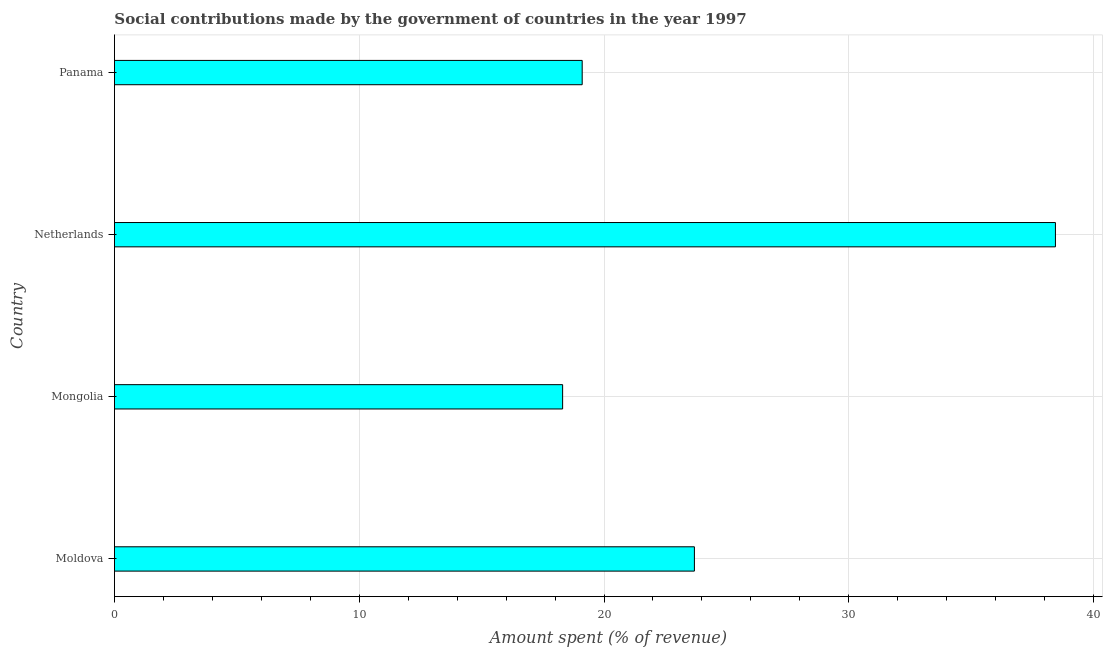Does the graph contain any zero values?
Provide a succinct answer. No. Does the graph contain grids?
Offer a terse response. Yes. What is the title of the graph?
Keep it short and to the point. Social contributions made by the government of countries in the year 1997. What is the label or title of the X-axis?
Your answer should be very brief. Amount spent (% of revenue). What is the amount spent in making social contributions in Mongolia?
Your answer should be very brief. 18.31. Across all countries, what is the maximum amount spent in making social contributions?
Your answer should be very brief. 38.44. Across all countries, what is the minimum amount spent in making social contributions?
Your answer should be compact. 18.31. In which country was the amount spent in making social contributions maximum?
Offer a terse response. Netherlands. In which country was the amount spent in making social contributions minimum?
Your answer should be very brief. Mongolia. What is the sum of the amount spent in making social contributions?
Ensure brevity in your answer.  99.56. What is the difference between the amount spent in making social contributions in Moldova and Netherlands?
Ensure brevity in your answer.  -14.75. What is the average amount spent in making social contributions per country?
Offer a very short reply. 24.89. What is the median amount spent in making social contributions?
Keep it short and to the point. 21.4. What is the ratio of the amount spent in making social contributions in Moldova to that in Netherlands?
Provide a succinct answer. 0.62. Is the difference between the amount spent in making social contributions in Mongolia and Netherlands greater than the difference between any two countries?
Offer a terse response. Yes. What is the difference between the highest and the second highest amount spent in making social contributions?
Provide a short and direct response. 14.75. Is the sum of the amount spent in making social contributions in Mongolia and Netherlands greater than the maximum amount spent in making social contributions across all countries?
Your answer should be compact. Yes. What is the difference between the highest and the lowest amount spent in making social contributions?
Offer a terse response. 20.13. In how many countries, is the amount spent in making social contributions greater than the average amount spent in making social contributions taken over all countries?
Your answer should be compact. 1. How many bars are there?
Provide a succinct answer. 4. Are all the bars in the graph horizontal?
Offer a terse response. Yes. How many countries are there in the graph?
Provide a short and direct response. 4. What is the difference between two consecutive major ticks on the X-axis?
Provide a short and direct response. 10. Are the values on the major ticks of X-axis written in scientific E-notation?
Give a very brief answer. No. What is the Amount spent (% of revenue) in Moldova?
Your response must be concise. 23.69. What is the Amount spent (% of revenue) of Mongolia?
Offer a very short reply. 18.31. What is the Amount spent (% of revenue) of Netherlands?
Keep it short and to the point. 38.44. What is the Amount spent (% of revenue) in Panama?
Make the answer very short. 19.11. What is the difference between the Amount spent (% of revenue) in Moldova and Mongolia?
Your answer should be compact. 5.38. What is the difference between the Amount spent (% of revenue) in Moldova and Netherlands?
Your answer should be compact. -14.75. What is the difference between the Amount spent (% of revenue) in Moldova and Panama?
Offer a terse response. 4.58. What is the difference between the Amount spent (% of revenue) in Mongolia and Netherlands?
Your response must be concise. -20.13. What is the difference between the Amount spent (% of revenue) in Mongolia and Panama?
Keep it short and to the point. -0.8. What is the difference between the Amount spent (% of revenue) in Netherlands and Panama?
Keep it short and to the point. 19.33. What is the ratio of the Amount spent (% of revenue) in Moldova to that in Mongolia?
Offer a terse response. 1.29. What is the ratio of the Amount spent (% of revenue) in Moldova to that in Netherlands?
Provide a short and direct response. 0.62. What is the ratio of the Amount spent (% of revenue) in Moldova to that in Panama?
Offer a terse response. 1.24. What is the ratio of the Amount spent (% of revenue) in Mongolia to that in Netherlands?
Provide a short and direct response. 0.48. What is the ratio of the Amount spent (% of revenue) in Mongolia to that in Panama?
Your answer should be compact. 0.96. What is the ratio of the Amount spent (% of revenue) in Netherlands to that in Panama?
Provide a short and direct response. 2.01. 